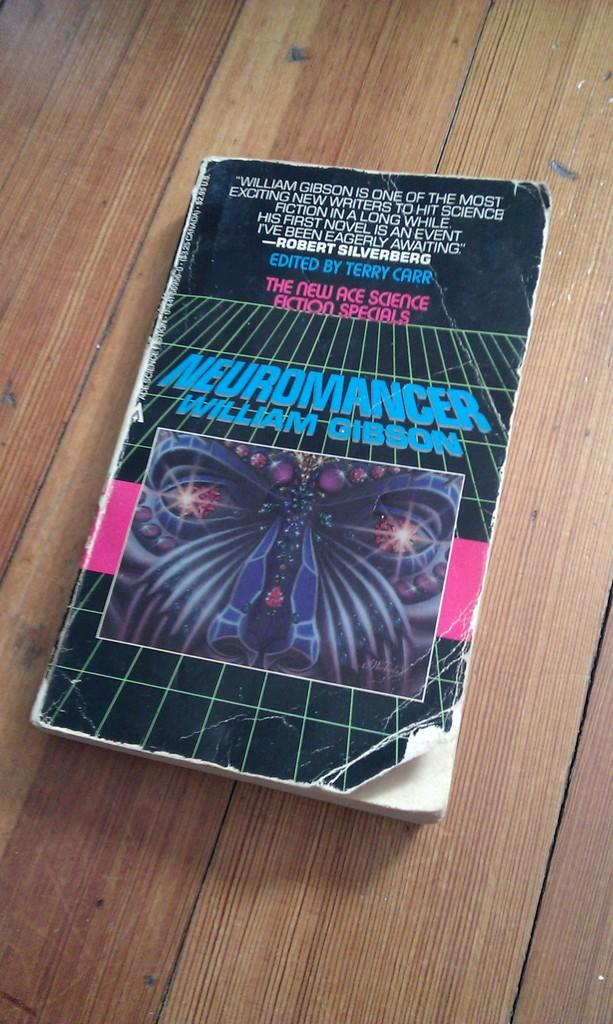Provide a one-sentence caption for the provided image. Old worn copy of Neuromancer book is on the wooden table. 